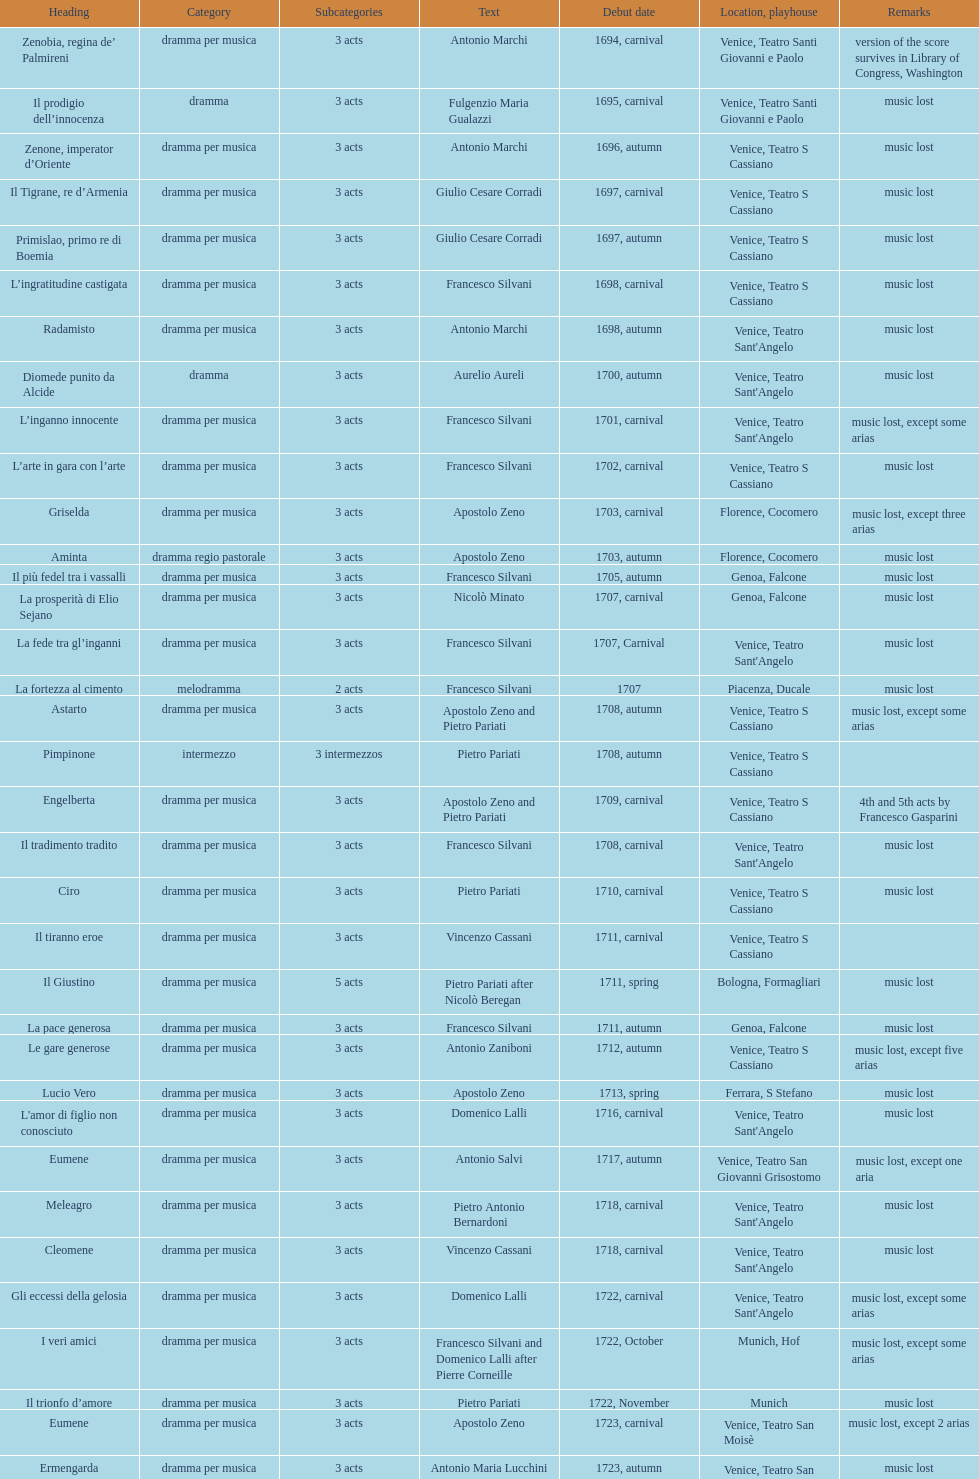How many were released after zenone, imperator d'oriente? 52. 